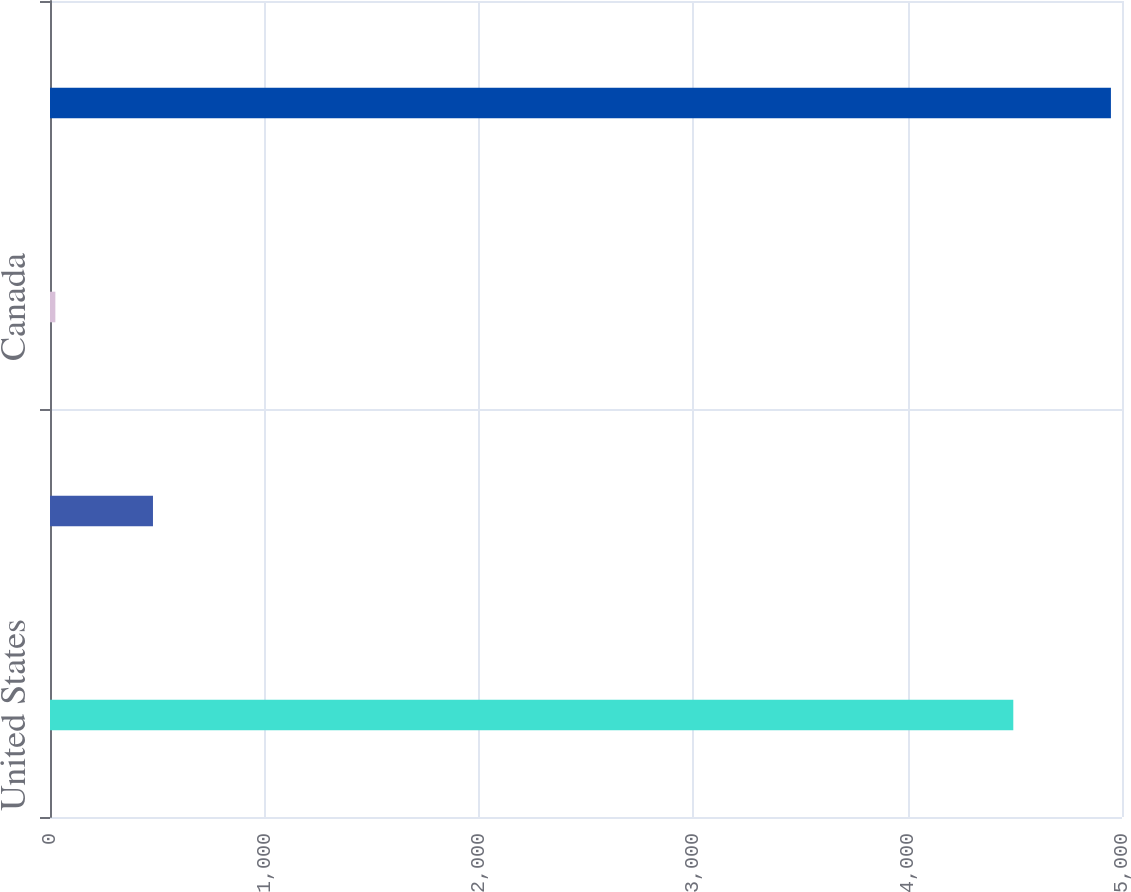Convert chart. <chart><loc_0><loc_0><loc_500><loc_500><bar_chart><fcel>United States<fcel>Trinidad<fcel>Canada<fcel>Total<nl><fcel>4493<fcel>480.3<fcel>25<fcel>4948.3<nl></chart> 